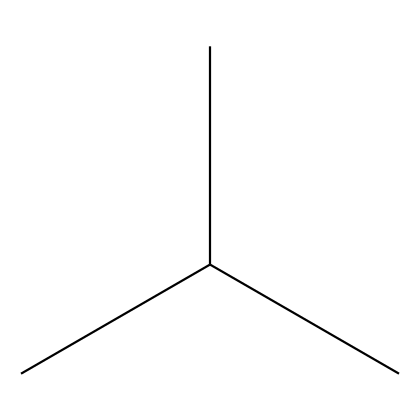What is the molecular formula of polyethylene? By analyzing the SMILES representation, CC(C)C indicates a structure with four carbon atoms (C) and can be deduced that hydrogen (H) atoms are added to satisfy the tetravalency of carbon. Therefore, the molecular formula can be deduced to be C4H10.
Answer: C4H10 How many carbon atoms are present in this chemical? The SMILES representation CC(C)C directly shows that there are four carbon atoms in total due to the presence of four 'C' symbols.
Answer: 4 What type of hydrocarbon is this molecule considered? This molecule does not contain any double or triple bonds and adheres to the alkane formula, indicating it is a saturated hydrocarbon.
Answer: saturated How many hydrogen atoms are associated with this molecule? In the molecular formula C4H10 identified earlier, ten hydrogen atoms are directly derived from the hydrocarbon’s nature and its structure based on the tetravalency of carbon.
Answer: 10 What is the degree of saturation of polyethylene? The degree of saturation indicates how many hydrogen atoms are present compared to a fully saturated hydrocarbon; since C4H10 contains the maximum number of hydrogens for four carbons, its degree of saturation is 4.
Answer: 4 